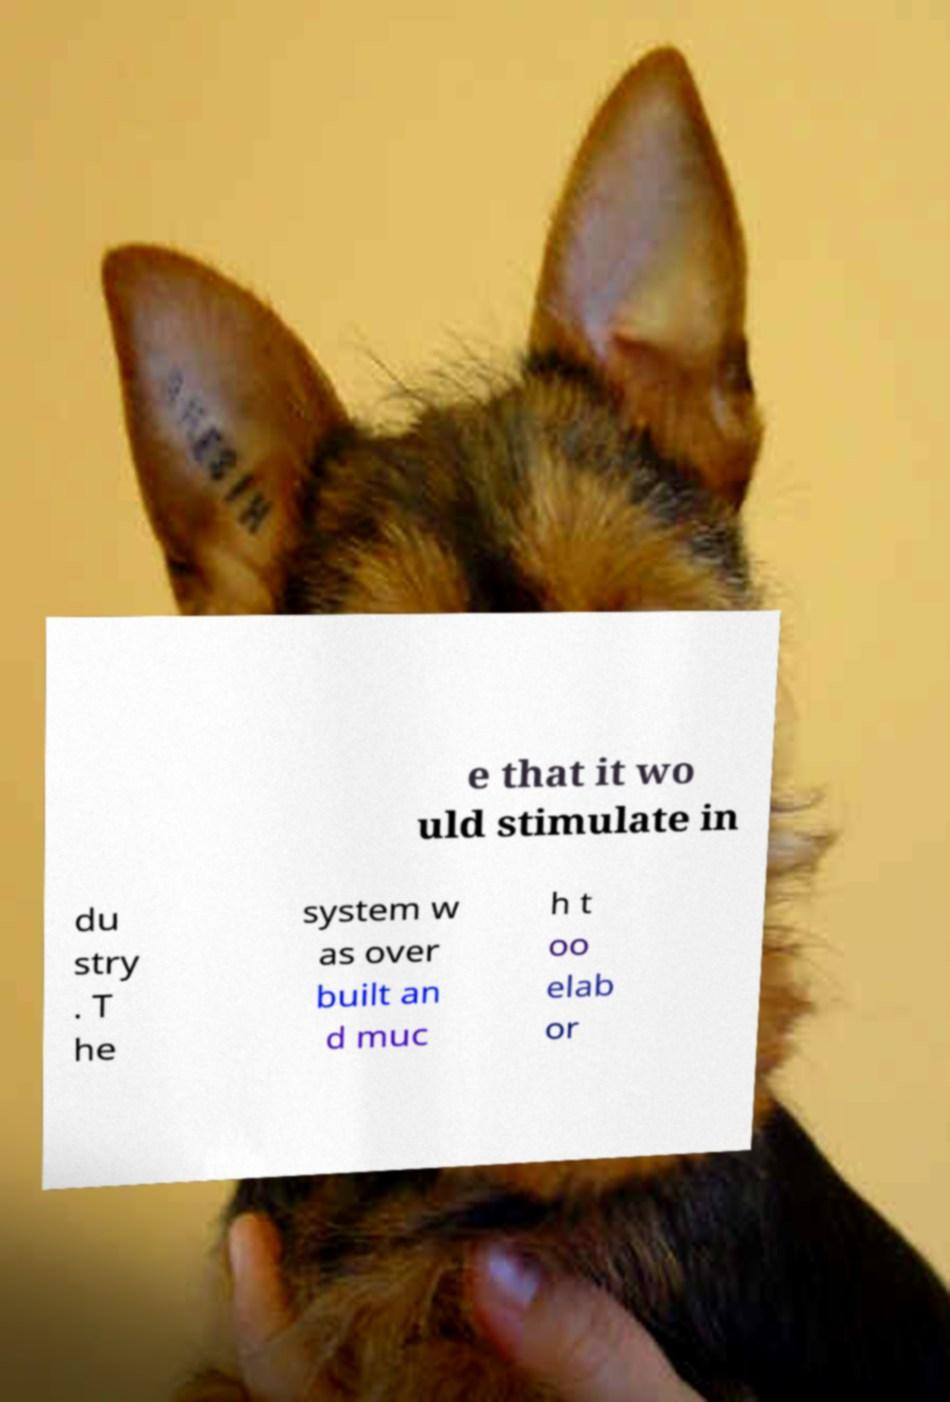For documentation purposes, I need the text within this image transcribed. Could you provide that? e that it wo uld stimulate in du stry . T he system w as over built an d muc h t oo elab or 